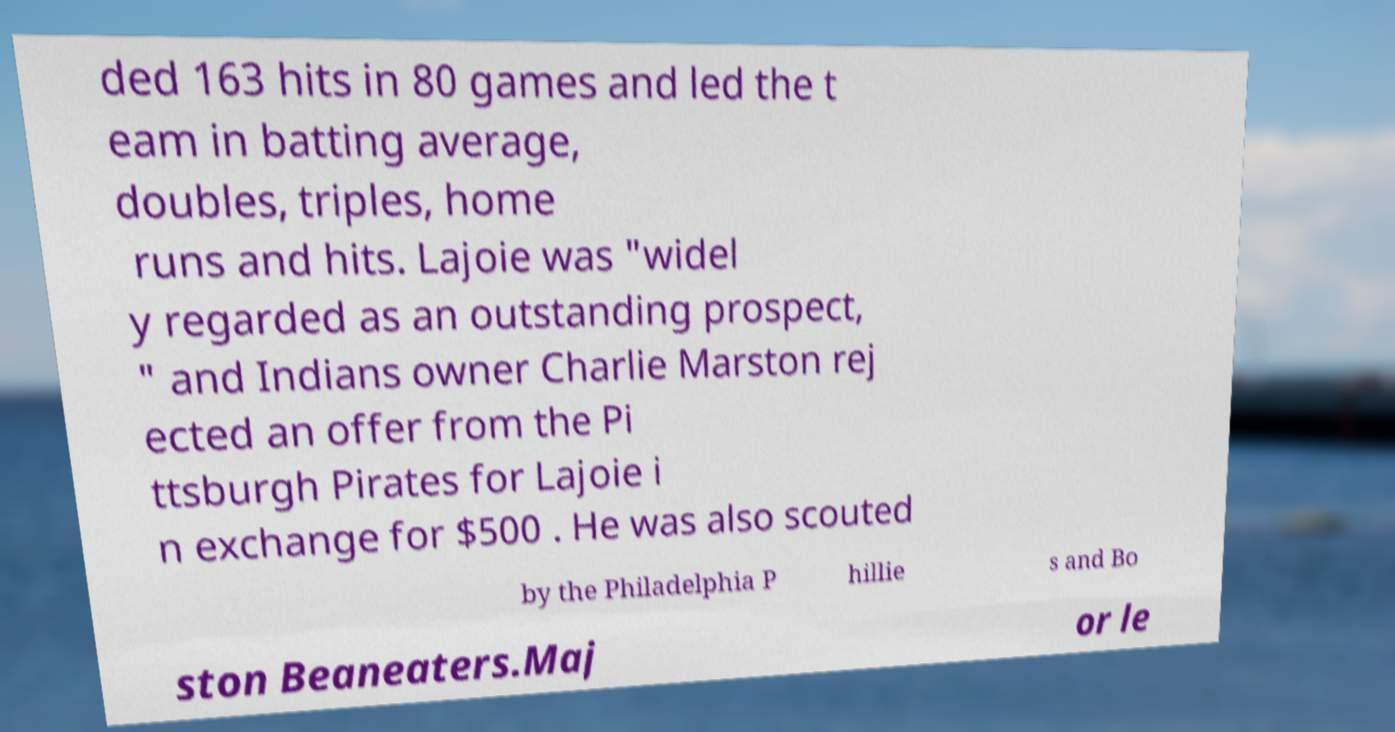Please read and relay the text visible in this image. What does it say? ded 163 hits in 80 games and led the t eam in batting average, doubles, triples, home runs and hits. Lajoie was "widel y regarded as an outstanding prospect, " and Indians owner Charlie Marston rej ected an offer from the Pi ttsburgh Pirates for Lajoie i n exchange for $500 . He was also scouted by the Philadelphia P hillie s and Bo ston Beaneaters.Maj or le 